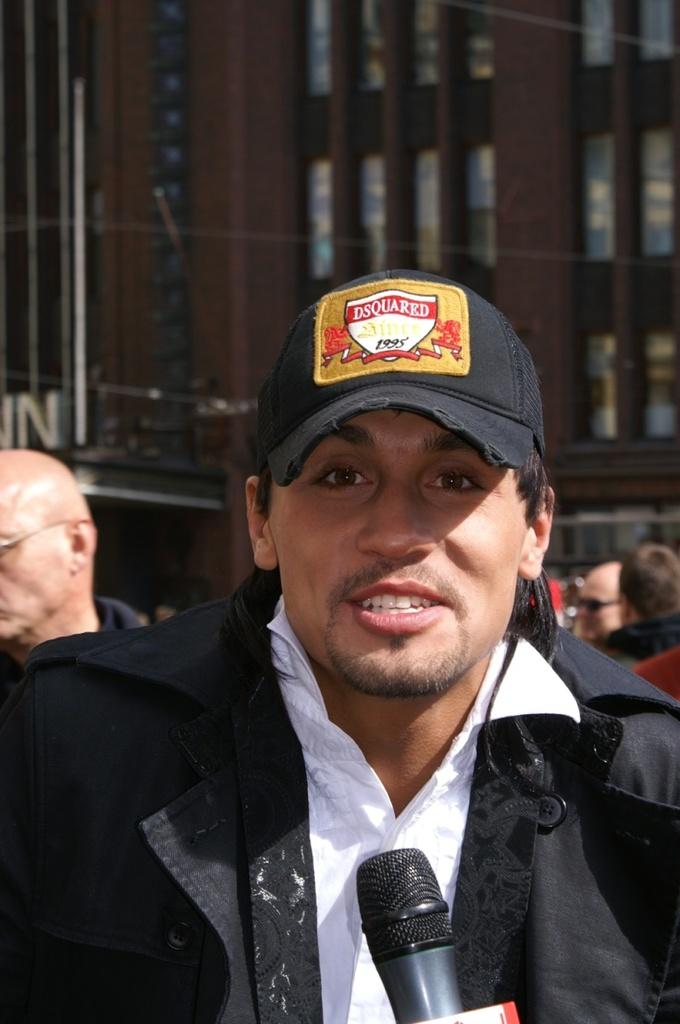Who or what can be seen in the image? There are people in the image. What object is present that is typically used for amplifying sound? There is a microphone (mic) in the image. What type of structure is visible in the image? There is a building in the image. What architectural feature can be seen in the building? There are windows visible in the image. Where is the shelf located in the image? There is no shelf present in the image. What type of cover is protecting the people in the image? There is no cover present in the image; the people are not protected by any cover. 